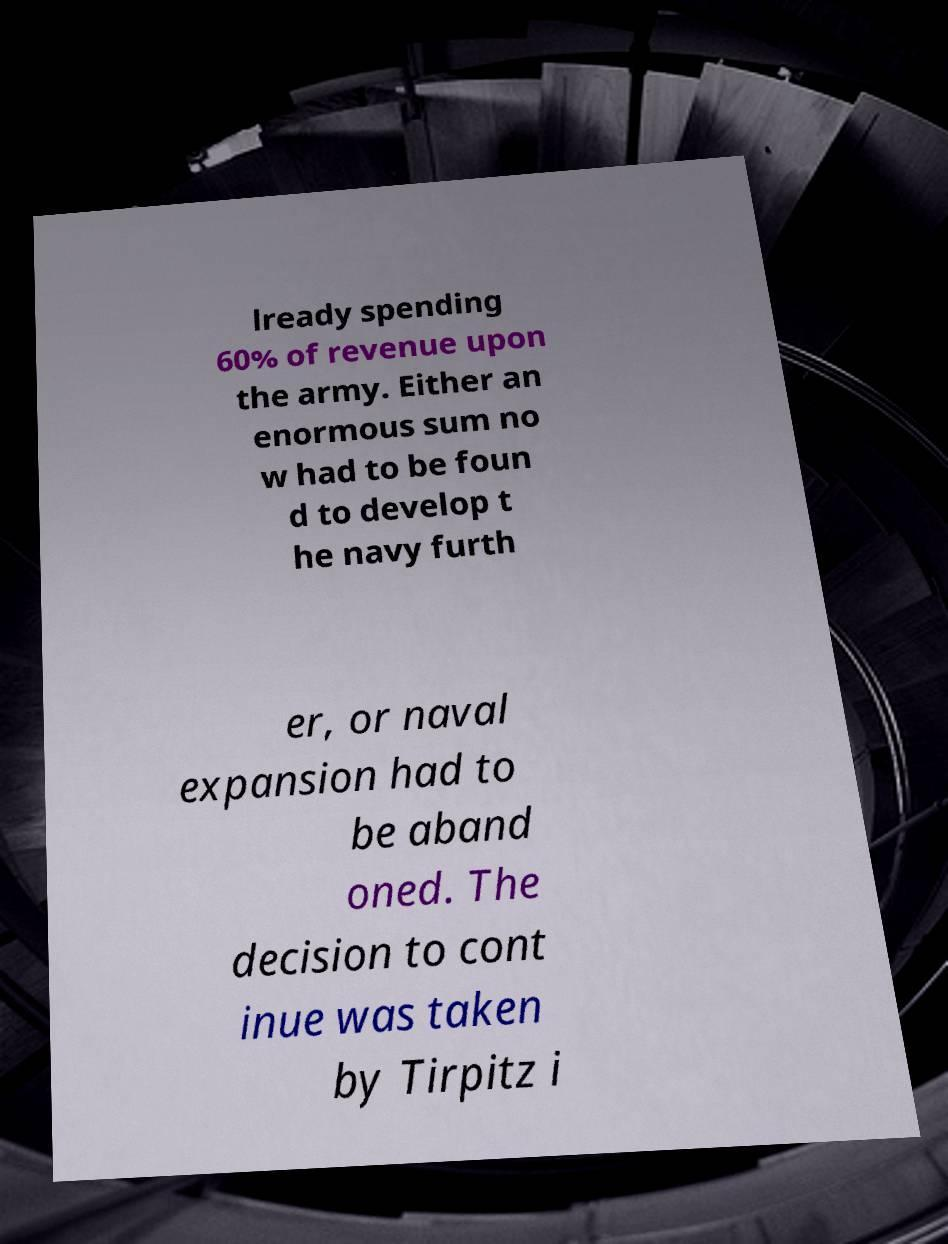Please read and relay the text visible in this image. What does it say? lready spending 60% of revenue upon the army. Either an enormous sum no w had to be foun d to develop t he navy furth er, or naval expansion had to be aband oned. The decision to cont inue was taken by Tirpitz i 